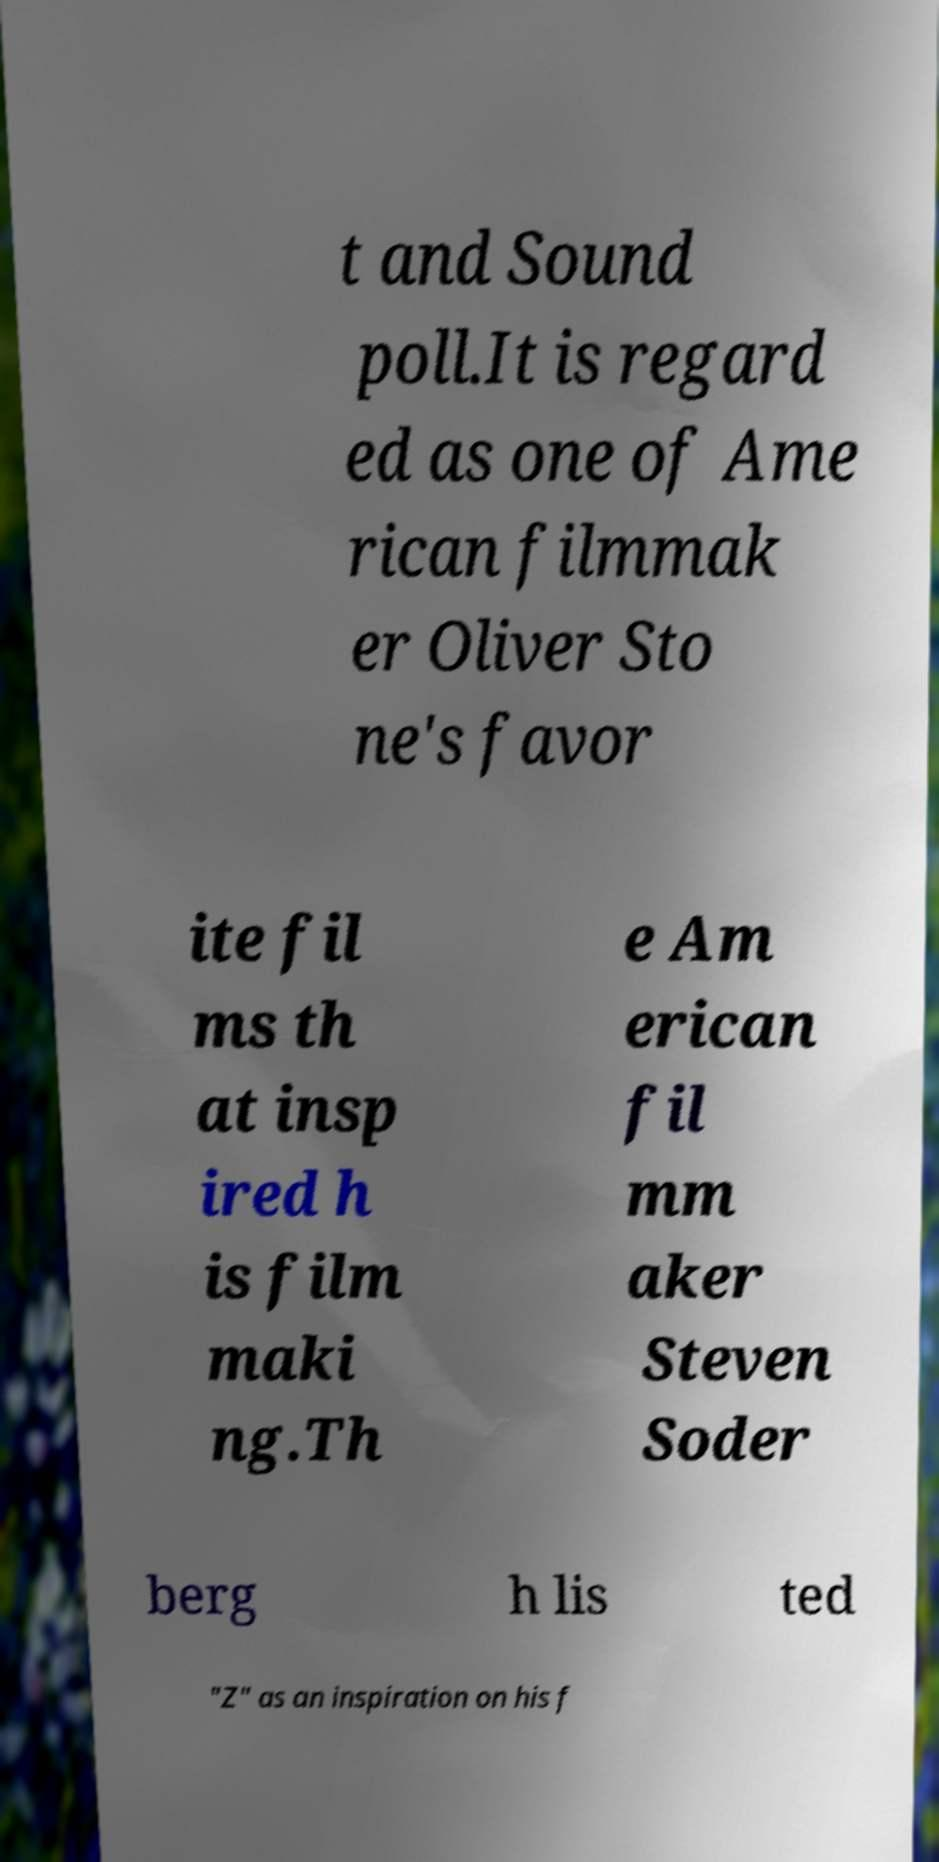Could you assist in decoding the text presented in this image and type it out clearly? t and Sound poll.It is regard ed as one of Ame rican filmmak er Oliver Sto ne's favor ite fil ms th at insp ired h is film maki ng.Th e Am erican fil mm aker Steven Soder berg h lis ted "Z" as an inspiration on his f 